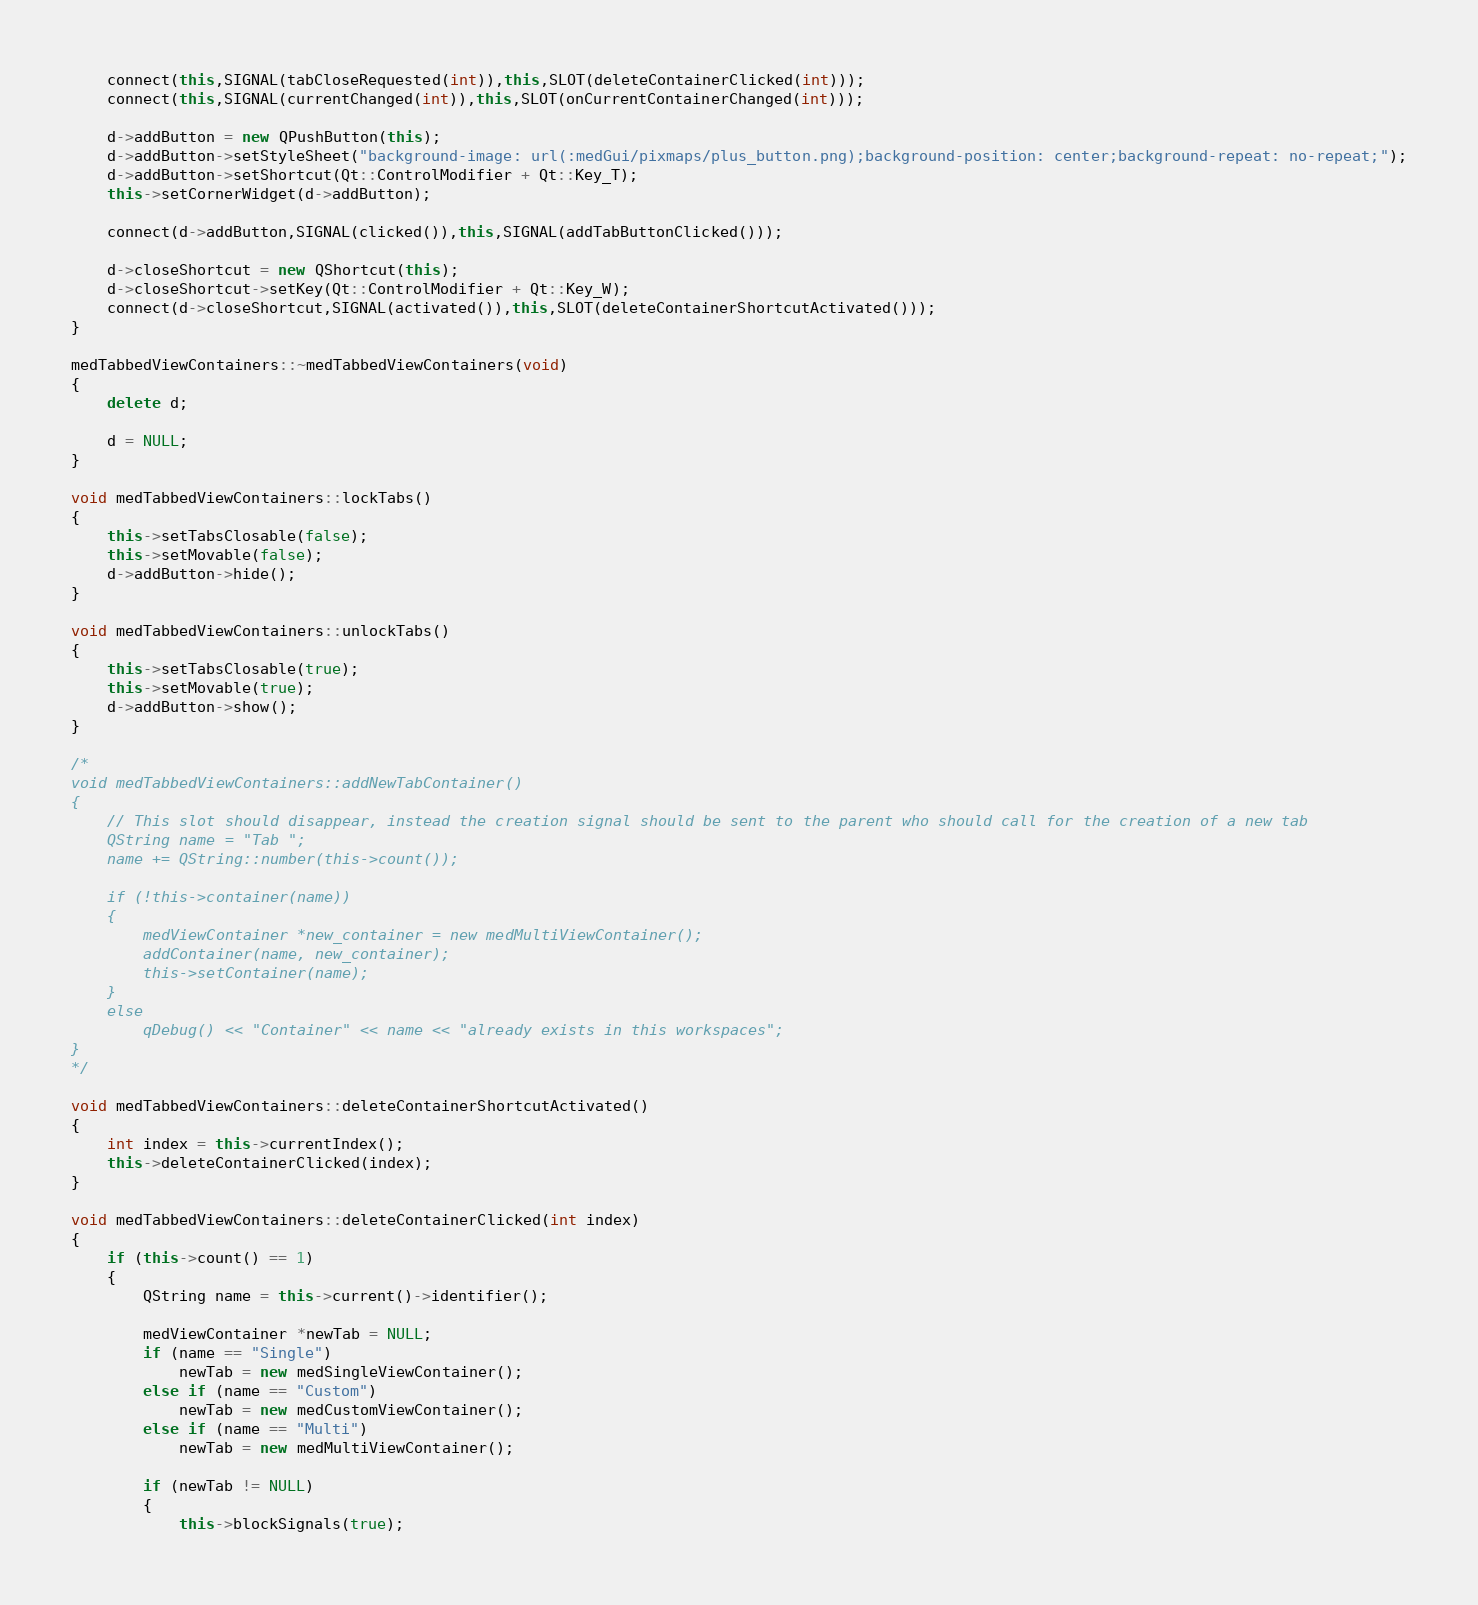<code> <loc_0><loc_0><loc_500><loc_500><_C++_>
    connect(this,SIGNAL(tabCloseRequested(int)),this,SLOT(deleteContainerClicked(int)));
    connect(this,SIGNAL(currentChanged(int)),this,SLOT(onCurrentContainerChanged(int)));

    d->addButton = new QPushButton(this);
    d->addButton->setStyleSheet("background-image: url(:medGui/pixmaps/plus_button.png);background-position: center;background-repeat: no-repeat;");
    d->addButton->setShortcut(Qt::ControlModifier + Qt::Key_T);
    this->setCornerWidget(d->addButton);

    connect(d->addButton,SIGNAL(clicked()),this,SIGNAL(addTabButtonClicked()));
    
    d->closeShortcut = new QShortcut(this);
    d->closeShortcut->setKey(Qt::ControlModifier + Qt::Key_W);
    connect(d->closeShortcut,SIGNAL(activated()),this,SLOT(deleteContainerShortcutActivated()));
}

medTabbedViewContainers::~medTabbedViewContainers(void)
{
    delete d;

    d = NULL;
}

void medTabbedViewContainers::lockTabs()
{
    this->setTabsClosable(false);
    this->setMovable(false);
    d->addButton->hide();
}

void medTabbedViewContainers::unlockTabs()
{
    this->setTabsClosable(true);
    this->setMovable(true);
    d->addButton->show();
}

/*
void medTabbedViewContainers::addNewTabContainer()
{
    // This slot should disappear, instead the creation signal should be sent to the parent who should call for the creation of a new tab
    QString name = "Tab ";
    name += QString::number(this->count());

    if (!this->container(name))
    {
        medViewContainer *new_container = new medMultiViewContainer();
        addContainer(name, new_container);
        this->setContainer(name);
    }
    else
        qDebug() << "Container" << name << "already exists in this workspaces";
}
*/

void medTabbedViewContainers::deleteContainerShortcutActivated()
{
    int index = this->currentIndex();
    this->deleteContainerClicked(index);
}

void medTabbedViewContainers::deleteContainerClicked(int index)
{
    if (this->count() == 1)
    {
        QString name = this->current()->identifier();

        medViewContainer *newTab = NULL;
        if (name == "Single")
            newTab = new medSingleViewContainer();
        else if (name == "Custom")
            newTab = new medCustomViewContainer();
        else if (name == "Multi")
            newTab = new medMultiViewContainer();

        if (newTab != NULL)
        {
            this->blockSignals(true);</code> 